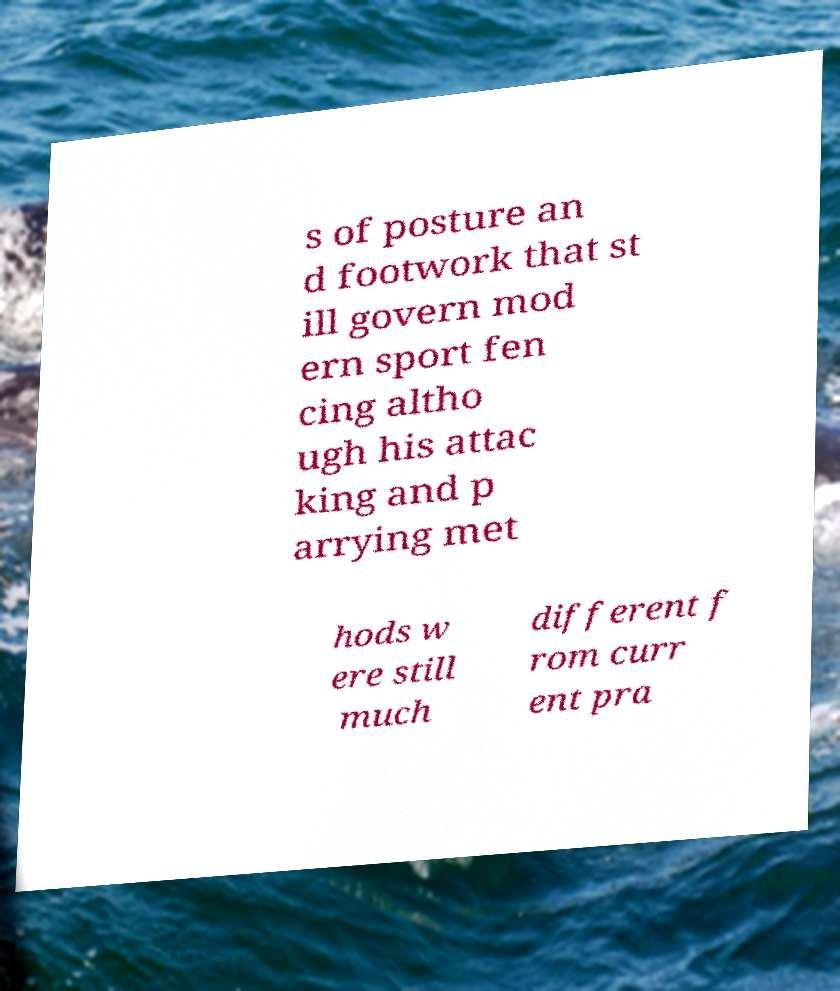Can you accurately transcribe the text from the provided image for me? s of posture an d footwork that st ill govern mod ern sport fen cing altho ugh his attac king and p arrying met hods w ere still much different f rom curr ent pra 